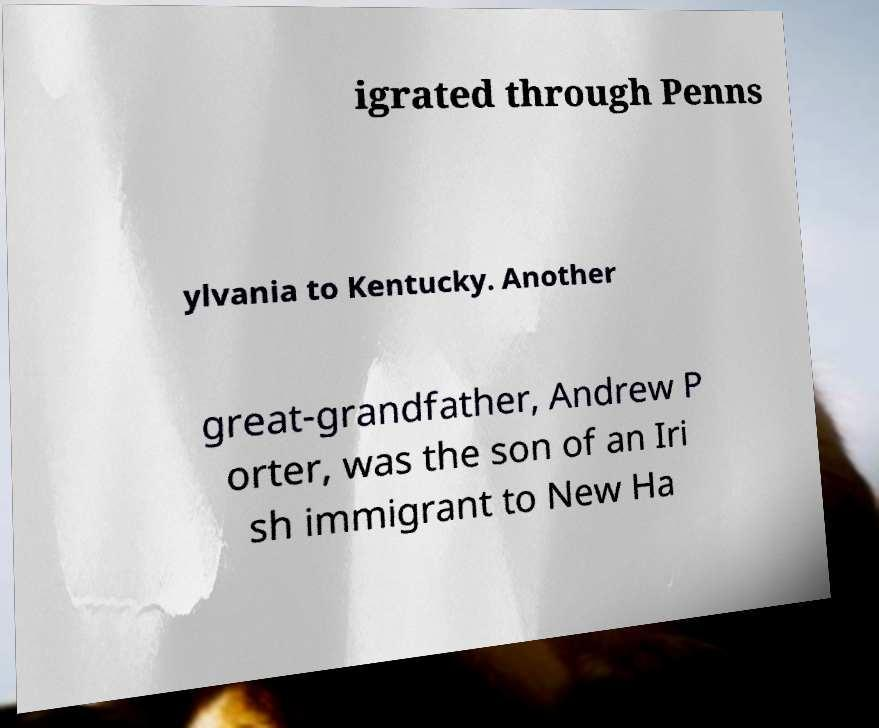Could you extract and type out the text from this image? igrated through Penns ylvania to Kentucky. Another great-grandfather, Andrew P orter, was the son of an Iri sh immigrant to New Ha 